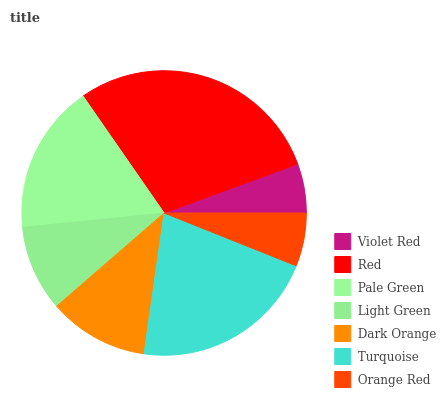Is Violet Red the minimum?
Answer yes or no. Yes. Is Red the maximum?
Answer yes or no. Yes. Is Pale Green the minimum?
Answer yes or no. No. Is Pale Green the maximum?
Answer yes or no. No. Is Red greater than Pale Green?
Answer yes or no. Yes. Is Pale Green less than Red?
Answer yes or no. Yes. Is Pale Green greater than Red?
Answer yes or no. No. Is Red less than Pale Green?
Answer yes or no. No. Is Dark Orange the high median?
Answer yes or no. Yes. Is Dark Orange the low median?
Answer yes or no. Yes. Is Light Green the high median?
Answer yes or no. No. Is Red the low median?
Answer yes or no. No. 